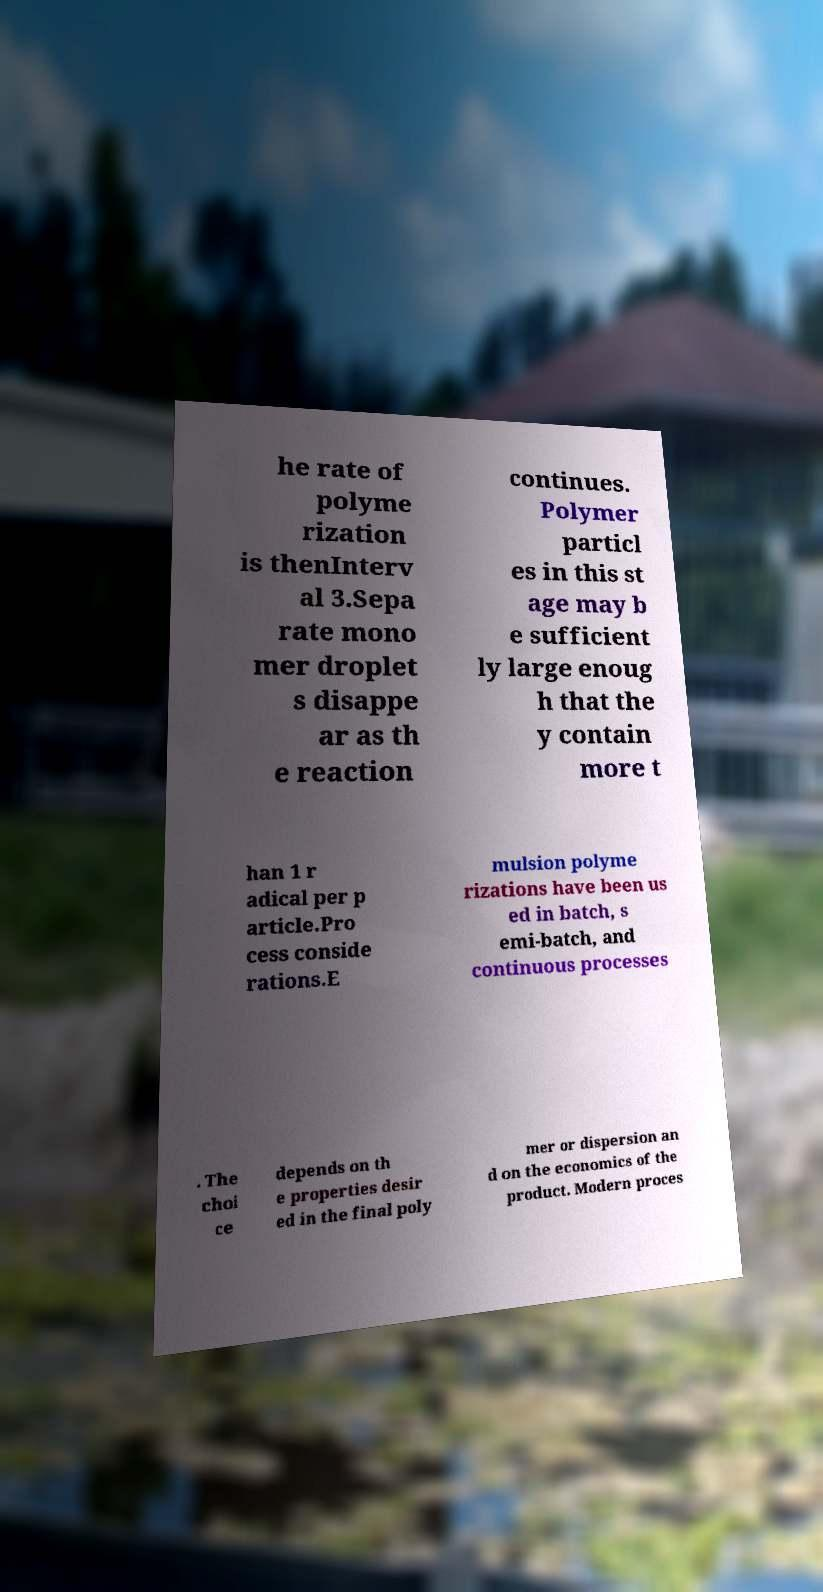Could you assist in decoding the text presented in this image and type it out clearly? he rate of polyme rization is thenInterv al 3.Sepa rate mono mer droplet s disappe ar as th e reaction continues. Polymer particl es in this st age may b e sufficient ly large enoug h that the y contain more t han 1 r adical per p article.Pro cess conside rations.E mulsion polyme rizations have been us ed in batch, s emi-batch, and continuous processes . The choi ce depends on th e properties desir ed in the final poly mer or dispersion an d on the economics of the product. Modern proces 